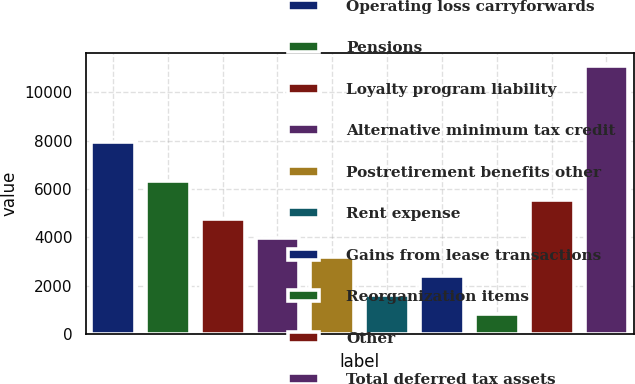Convert chart. <chart><loc_0><loc_0><loc_500><loc_500><bar_chart><fcel>Operating loss carryforwards<fcel>Pensions<fcel>Loyalty program liability<fcel>Alternative minimum tax credit<fcel>Postretirement benefits other<fcel>Rent expense<fcel>Gains from lease transactions<fcel>Reorganization items<fcel>Other<fcel>Total deferred tax assets<nl><fcel>7923<fcel>6342.8<fcel>4762.6<fcel>3972.5<fcel>3182.4<fcel>1602.2<fcel>2392.3<fcel>812.1<fcel>5552.7<fcel>11083.4<nl></chart> 